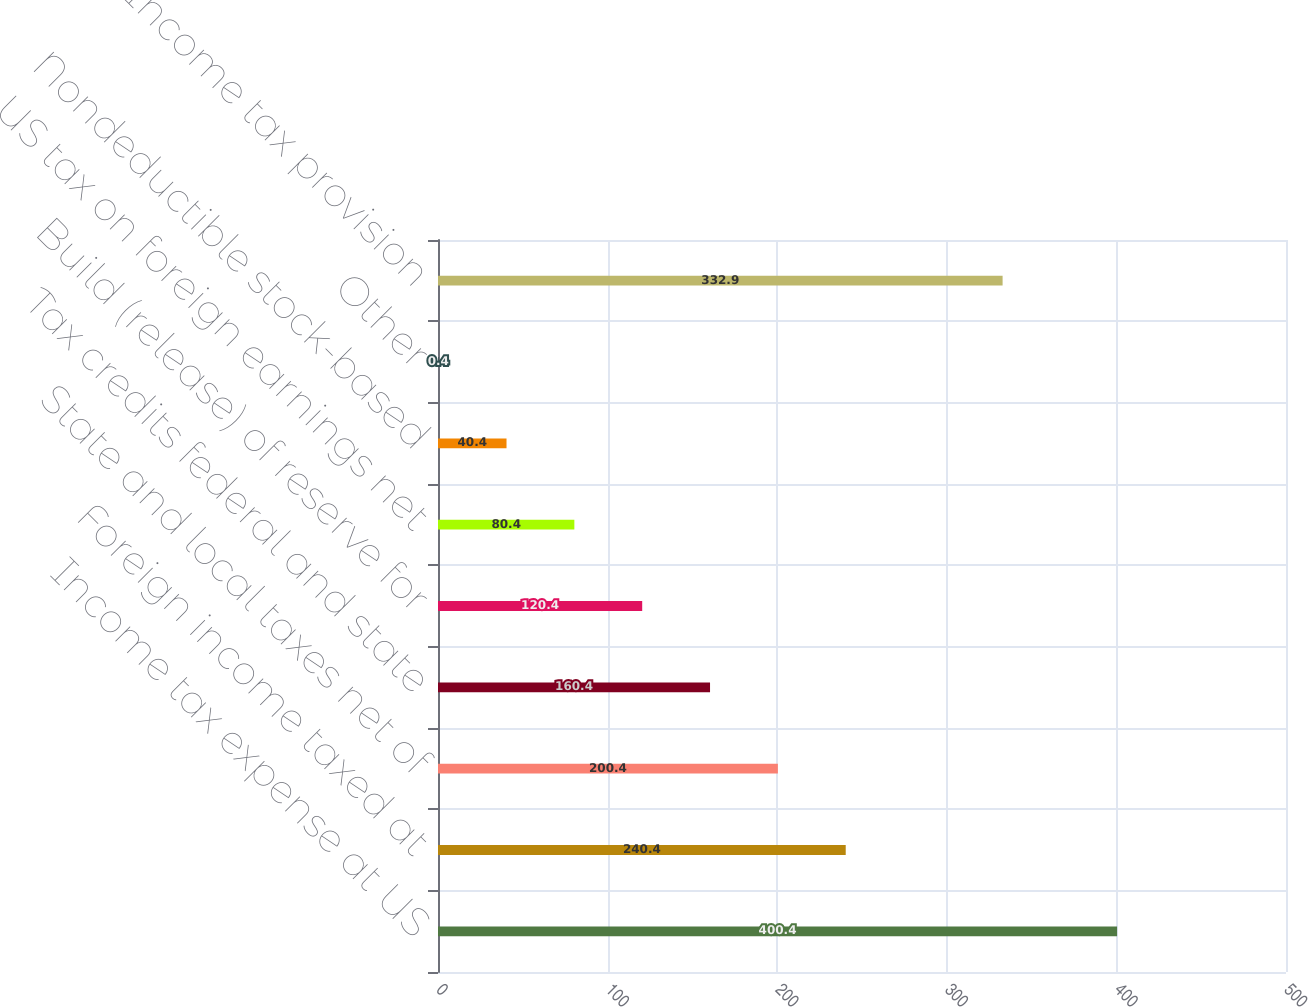<chart> <loc_0><loc_0><loc_500><loc_500><bar_chart><fcel>Income tax expense at US<fcel>Foreign income taxed at<fcel>State and local taxes net of<fcel>Tax credits federal and state<fcel>Build (release) of reserve for<fcel>US tax on foreign earnings net<fcel>Nondeductible stock-based<fcel>Other<fcel>Income tax provision<nl><fcel>400.4<fcel>240.4<fcel>200.4<fcel>160.4<fcel>120.4<fcel>80.4<fcel>40.4<fcel>0.4<fcel>332.9<nl></chart> 